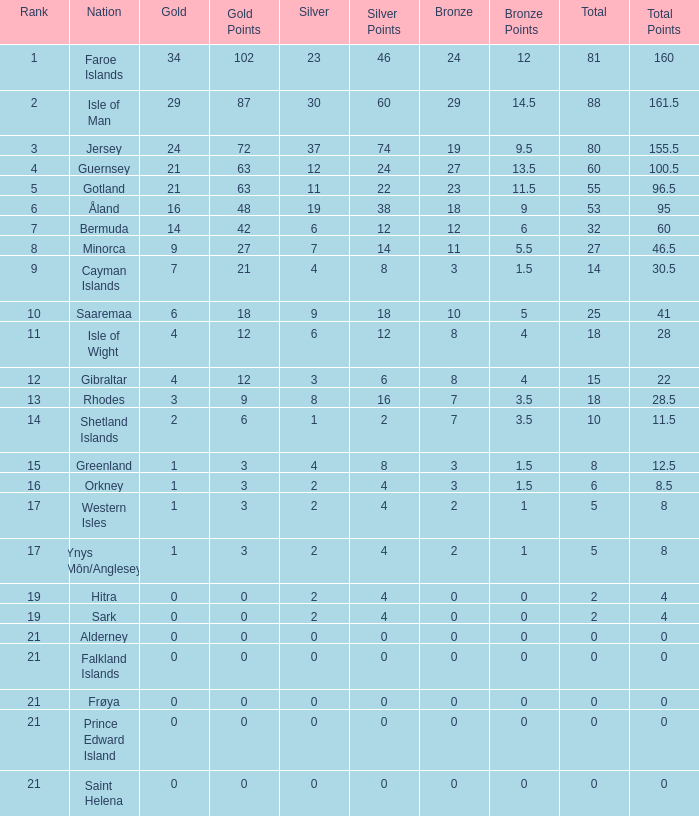How many Silver medals were won in total by all those with more than 3 bronze and exactly 16 gold? 19.0. 